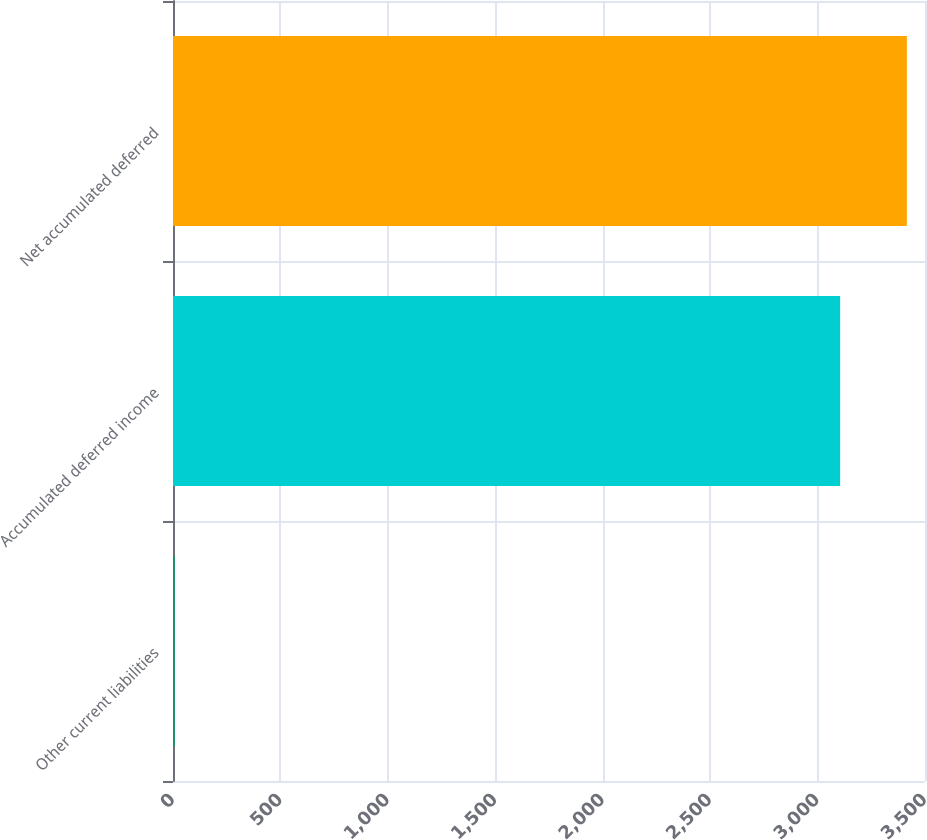<chart> <loc_0><loc_0><loc_500><loc_500><bar_chart><fcel>Other current liabilities<fcel>Accumulated deferred income<fcel>Net accumulated deferred<nl><fcel>8<fcel>3105<fcel>3415.5<nl></chart> 